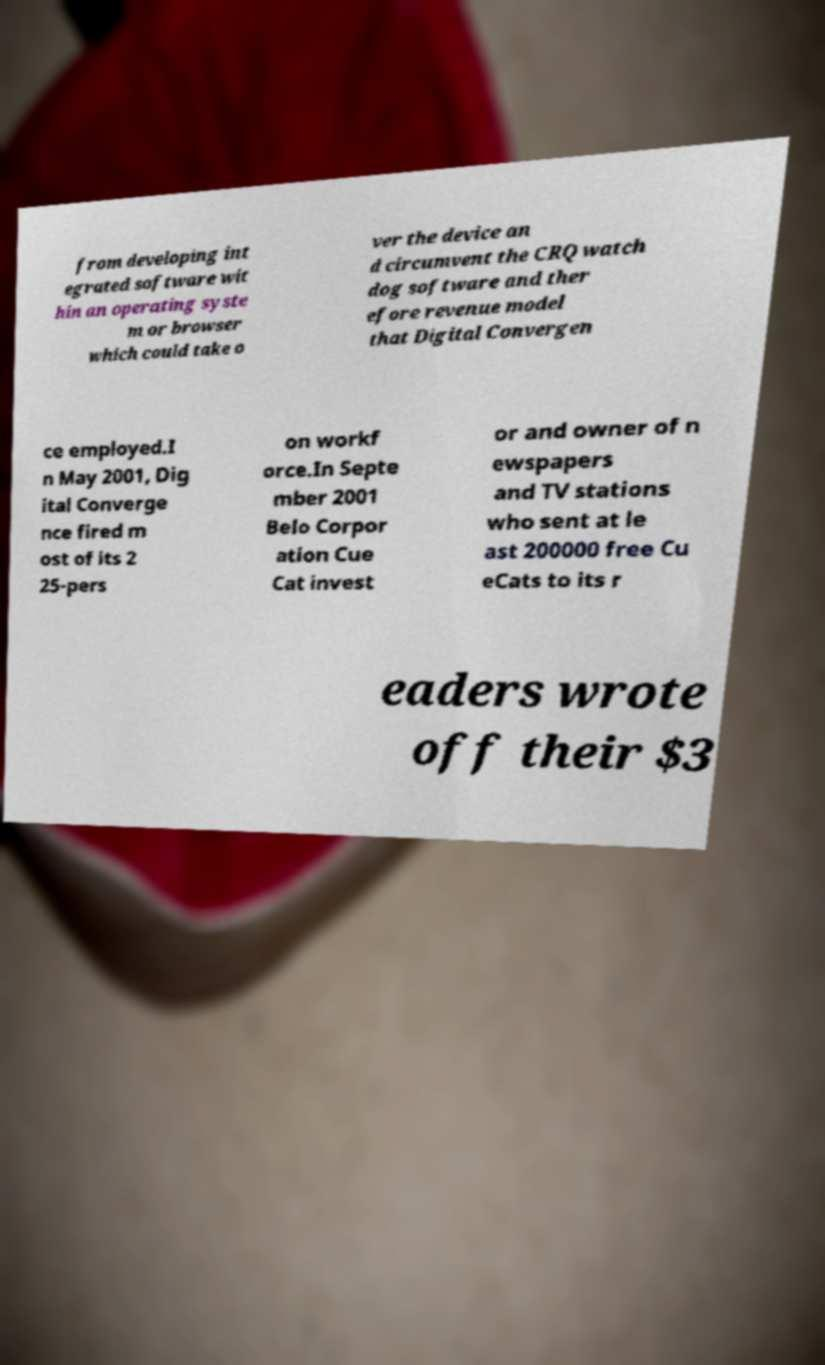Can you read and provide the text displayed in the image?This photo seems to have some interesting text. Can you extract and type it out for me? from developing int egrated software wit hin an operating syste m or browser which could take o ver the device an d circumvent the CRQ watch dog software and ther efore revenue model that Digital Convergen ce employed.I n May 2001, Dig ital Converge nce fired m ost of its 2 25-pers on workf orce.In Septe mber 2001 Belo Corpor ation Cue Cat invest or and owner of n ewspapers and TV stations who sent at le ast 200000 free Cu eCats to its r eaders wrote off their $3 